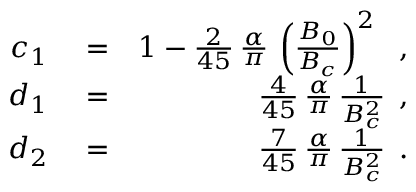Convert formula to latex. <formula><loc_0><loc_0><loc_500><loc_500>\begin{array} { r l r } { c _ { 1 } } & = } & { 1 - \frac { 2 } { 4 5 } \, \frac { \alpha } { \pi } \, \left ( \frac { B _ { 0 } } { B _ { c } } \right ) ^ { 2 } \, , } \\ { d _ { 1 } } & = } & { \frac { 4 } { 4 5 } \, \frac { \alpha } { \pi } \, \frac { 1 } { B _ { c } ^ { 2 } } \, , } \\ { d _ { 2 } } & = } & { \frac { 7 } { 4 5 } \, \frac { \alpha } { \pi } \, \frac { 1 } { B _ { c } ^ { 2 } } \, . } \end{array}</formula> 